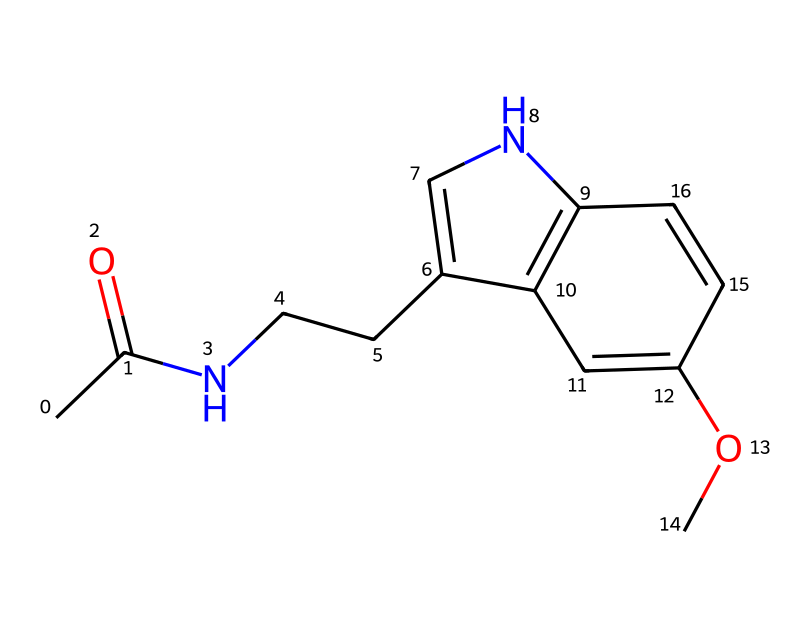how many carbon atoms are in melatonin? The SMILES representation shows the structure of melatonin, and counting the 'C's, we find a total of 13 carbon atoms.
Answer: 13 how many nitrogen atoms are present in the structure? In the SMILES notation, there are two 'N' symbols, indicating the presence of two nitrogen atoms in melatonin.
Answer: 2 what functional group is indicated by the presence of CC(=O)? The 'CC(=O)' portion indicates a carbonyl group (C=O), as the 'O' is double-bonded to a 'C', characterizing an acetamide functional group in the structure.
Answer: acetamide does melatonin contain any aromatic rings? The presence of C=C bonds and interconnected carbon atoms suggests that there are aromatic rings in the structure, specifically benzene-like rings due to alternating double bonds.
Answer: yes what type of chemical is melatonin classified as? Given its structure which contains a side chain with nitrogen and exhibits both amide and aromatic characteristics, it is classified as an indole-derived compound, specifically a tryptamine.
Answer: tryptamine what is the total number of double bonds in this structure? By analyzing the structure, we can see a total of 5 double bonds, indicated by the '=' signs in the SMILES representation.
Answer: 5 which part of melatonin contributes to its ability to regulate sleep? The presence of the indole structure, which is crucial for melatonin's interaction with melatonin receptors, is essential in regulating sleep.
Answer: indole structure 